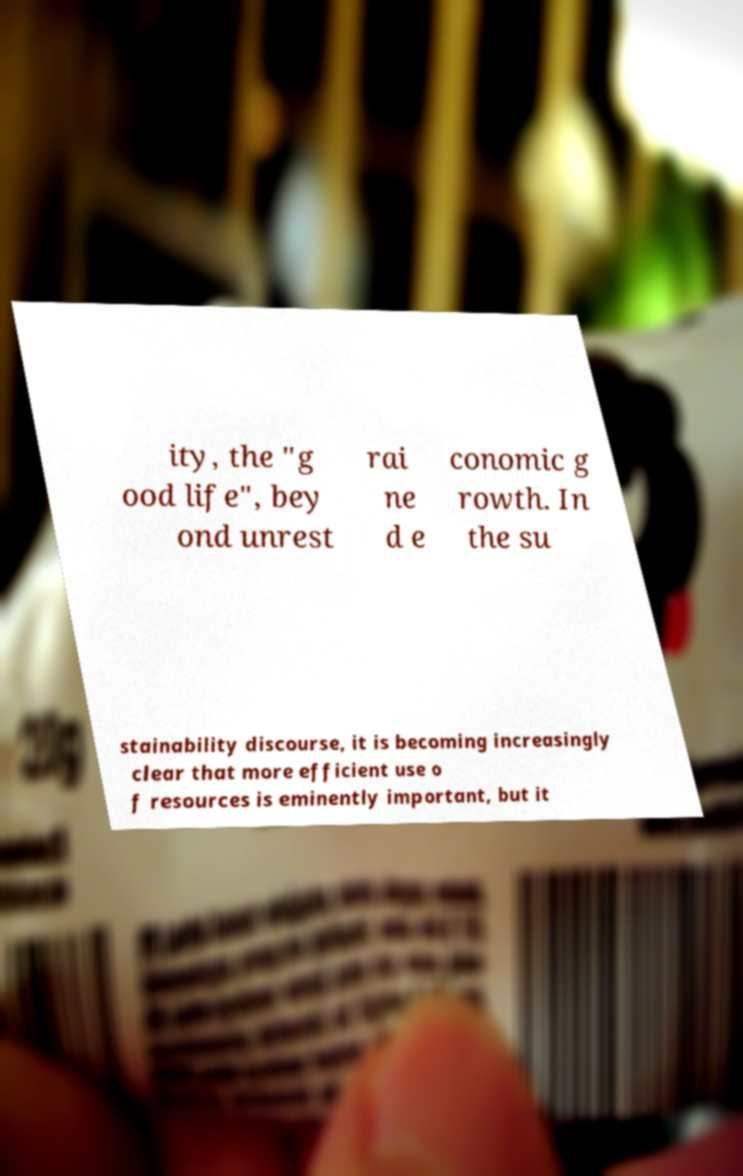For documentation purposes, I need the text within this image transcribed. Could you provide that? ity, the "g ood life", bey ond unrest rai ne d e conomic g rowth. In the su stainability discourse, it is becoming increasingly clear that more efficient use o f resources is eminently important, but it 